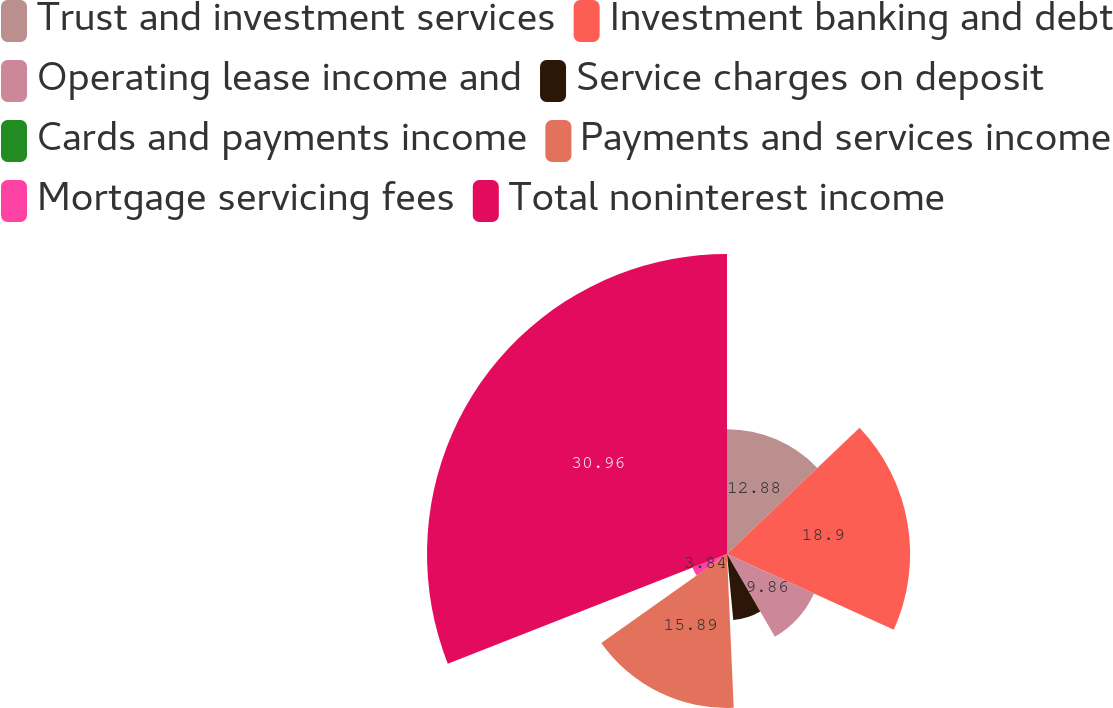<chart> <loc_0><loc_0><loc_500><loc_500><pie_chart><fcel>Trust and investment services<fcel>Investment banking and debt<fcel>Operating lease income and<fcel>Service charges on deposit<fcel>Cards and payments income<fcel>Payments and services income<fcel>Mortgage servicing fees<fcel>Total noninterest income<nl><fcel>12.88%<fcel>18.9%<fcel>9.86%<fcel>6.85%<fcel>0.82%<fcel>15.89%<fcel>3.84%<fcel>30.96%<nl></chart> 